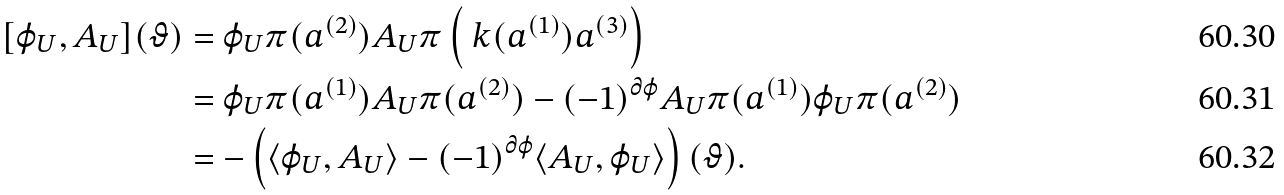Convert formula to latex. <formula><loc_0><loc_0><loc_500><loc_500>[ \varphi _ { U } , A _ { U } ] ( \vartheta ) & = \varphi _ { U } \pi ( a ^ { ( 2 ) } ) A _ { U } \pi \left ( \ k ( a ^ { ( 1 ) } ) a ^ { ( 3 ) } \right ) \\ & = \varphi _ { U } \pi ( a ^ { ( 1 ) } ) A _ { U } \pi ( a ^ { ( 2 ) } ) - ( - 1 ) ^ { \partial \varphi } A _ { U } \pi ( a ^ { ( 1 ) } ) \varphi _ { U } \pi ( a ^ { ( 2 ) } ) \\ & = - \left ( \langle \varphi _ { U } , A _ { U } \rangle - ( - 1 ) ^ { \partial \varphi } \langle A _ { U } , \varphi _ { U } \rangle \right ) ( \vartheta ) .</formula> 